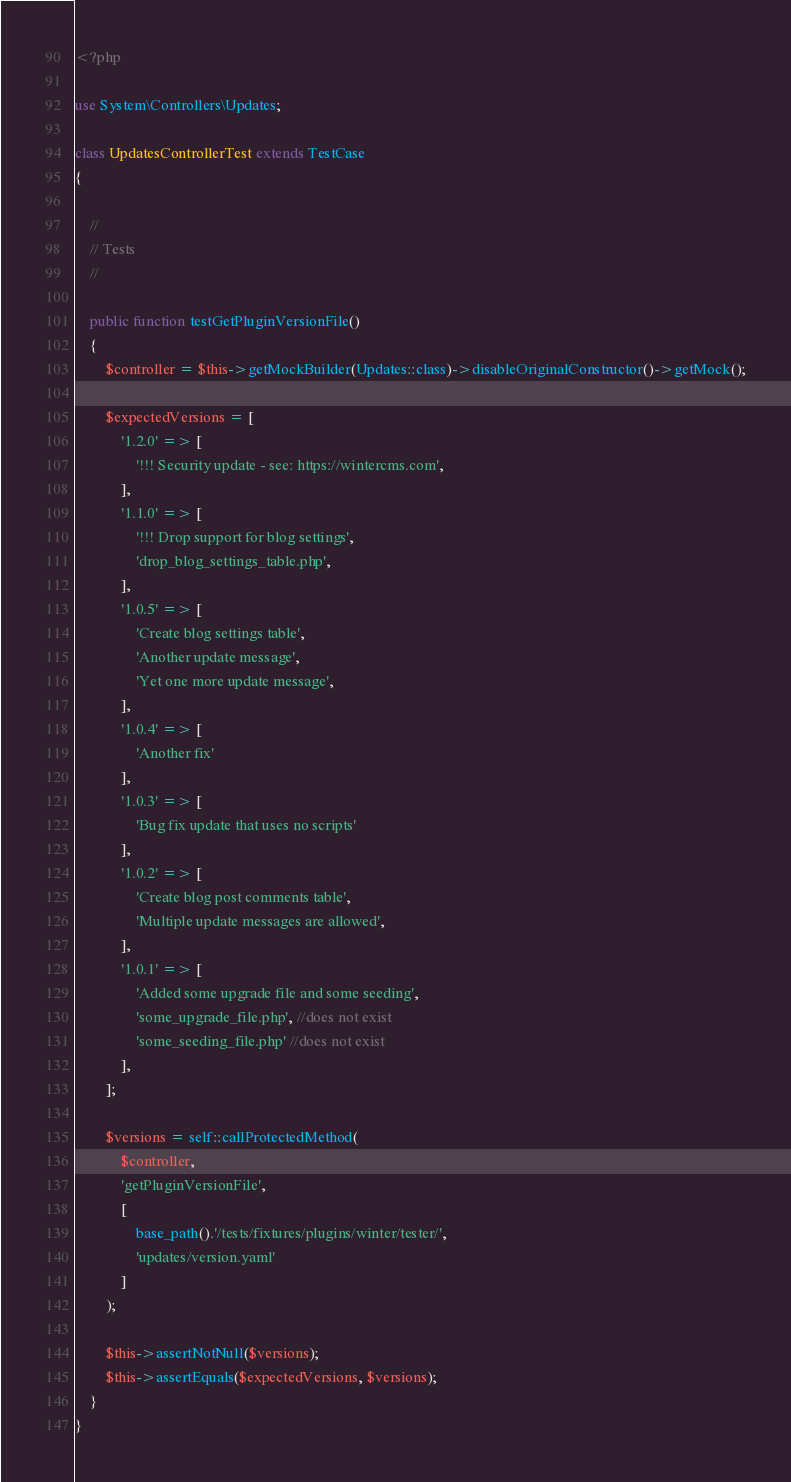<code> <loc_0><loc_0><loc_500><loc_500><_PHP_><?php

use System\Controllers\Updates;

class UpdatesControllerTest extends TestCase
{

    //
    // Tests
    //

    public function testGetPluginVersionFile()
    {
        $controller = $this->getMockBuilder(Updates::class)->disableOriginalConstructor()->getMock();

        $expectedVersions = [
            '1.2.0' => [
                '!!! Security update - see: https://wintercms.com',
            ],
            '1.1.0' => [
                '!!! Drop support for blog settings',
                'drop_blog_settings_table.php',
            ],
            '1.0.5' => [
                'Create blog settings table',
                'Another update message',
                'Yet one more update message',
            ],
            '1.0.4' => [
                'Another fix'
            ],
            '1.0.3' => [
                'Bug fix update that uses no scripts'
            ],
            '1.0.2' => [
                'Create blog post comments table',
                'Multiple update messages are allowed',
            ],
            '1.0.1' => [
                'Added some upgrade file and some seeding',
                'some_upgrade_file.php', //does not exist
                'some_seeding_file.php' //does not exist
            ],
        ];

        $versions = self::callProtectedMethod(
            $controller,
            'getPluginVersionFile',
            [
                base_path().'/tests/fixtures/plugins/winter/tester/',
                'updates/version.yaml'
            ]
        );

        $this->assertNotNull($versions);
        $this->assertEquals($expectedVersions, $versions);
    }
}
</code> 